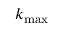<formula> <loc_0><loc_0><loc_500><loc_500>k _ { \max }</formula> 